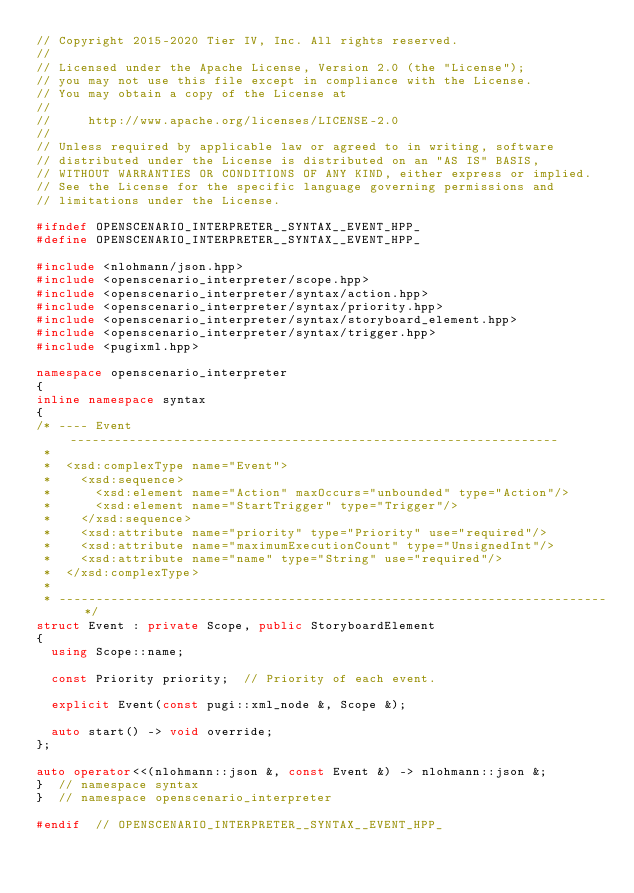Convert code to text. <code><loc_0><loc_0><loc_500><loc_500><_C++_>// Copyright 2015-2020 Tier IV, Inc. All rights reserved.
//
// Licensed under the Apache License, Version 2.0 (the "License");
// you may not use this file except in compliance with the License.
// You may obtain a copy of the License at
//
//     http://www.apache.org/licenses/LICENSE-2.0
//
// Unless required by applicable law or agreed to in writing, software
// distributed under the License is distributed on an "AS IS" BASIS,
// WITHOUT WARRANTIES OR CONDITIONS OF ANY KIND, either express or implied.
// See the License for the specific language governing permissions and
// limitations under the License.

#ifndef OPENSCENARIO_INTERPRETER__SYNTAX__EVENT_HPP_
#define OPENSCENARIO_INTERPRETER__SYNTAX__EVENT_HPP_

#include <nlohmann/json.hpp>
#include <openscenario_interpreter/scope.hpp>
#include <openscenario_interpreter/syntax/action.hpp>
#include <openscenario_interpreter/syntax/priority.hpp>
#include <openscenario_interpreter/syntax/storyboard_element.hpp>
#include <openscenario_interpreter/syntax/trigger.hpp>
#include <pugixml.hpp>

namespace openscenario_interpreter
{
inline namespace syntax
{
/* ---- Event ------------------------------------------------------------------
 *
 *  <xsd:complexType name="Event">
 *    <xsd:sequence>
 *      <xsd:element name="Action" maxOccurs="unbounded" type="Action"/>
 *      <xsd:element name="StartTrigger" type="Trigger"/>
 *    </xsd:sequence>
 *    <xsd:attribute name="priority" type="Priority" use="required"/>
 *    <xsd:attribute name="maximumExecutionCount" type="UnsignedInt"/>
 *    <xsd:attribute name="name" type="String" use="required"/>
 *  </xsd:complexType>
 *
 * -------------------------------------------------------------------------- */
struct Event : private Scope, public StoryboardElement
{
  using Scope::name;

  const Priority priority;  // Priority of each event.

  explicit Event(const pugi::xml_node &, Scope &);

  auto start() -> void override;
};

auto operator<<(nlohmann::json &, const Event &) -> nlohmann::json &;
}  // namespace syntax
}  // namespace openscenario_interpreter

#endif  // OPENSCENARIO_INTERPRETER__SYNTAX__EVENT_HPP_
</code> 